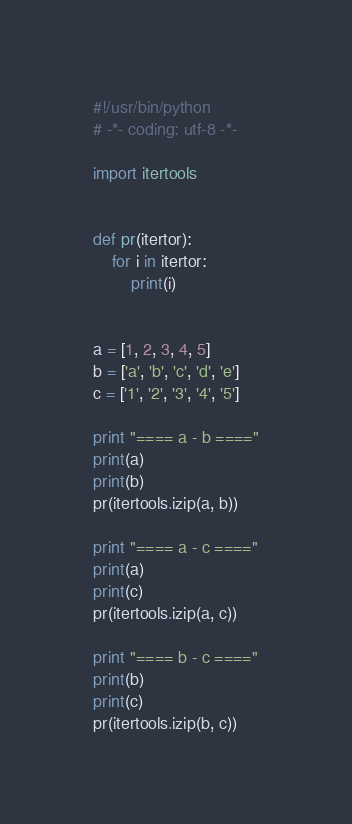<code> <loc_0><loc_0><loc_500><loc_500><_Python_>#!/usr/bin/python
# -*- coding: utf-8 -*-

import itertools


def pr(itertor):
    for i in itertor:
        print(i)


a = [1, 2, 3, 4, 5]
b = ['a', 'b', 'c', 'd', 'e']
c = ['1', '2', '3', '4', '5']

print "==== a - b ===="
print(a)
print(b)
pr(itertools.izip(a, b))

print "==== a - c ===="
print(a)
print(c)
pr(itertools.izip(a, c))

print "==== b - c ===="
print(b)
print(c)
pr(itertools.izip(b, c))
</code> 